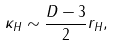Convert formula to latex. <formula><loc_0><loc_0><loc_500><loc_500>\kappa _ { H } \sim \frac { D - 3 } { 2 } r _ { H } ,</formula> 